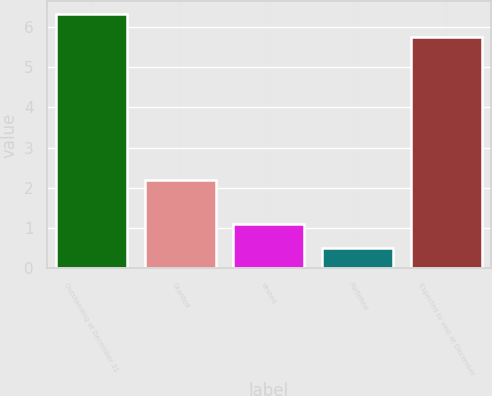<chart> <loc_0><loc_0><loc_500><loc_500><bar_chart><fcel>Outstanding at December 31<fcel>Granted<fcel>Vested<fcel>Forfeited<fcel>Expected to vest at December<nl><fcel>6.32<fcel>2.2<fcel>1.1<fcel>0.5<fcel>5.76<nl></chart> 